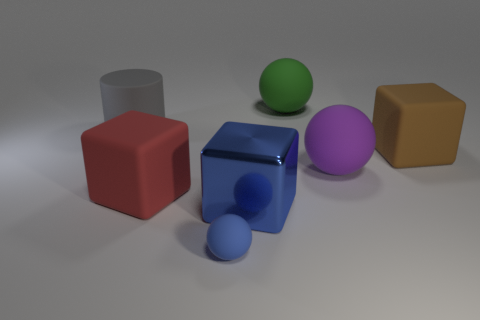Are there any other things that are the same material as the large blue thing?
Your response must be concise. No. Is the number of big cylinders to the right of the big metal block less than the number of large purple balls that are right of the tiny object?
Your response must be concise. Yes. There is a big purple matte object that is right of the object behind the gray object; what is its shape?
Your response must be concise. Sphere. Are any large green objects visible?
Your response must be concise. Yes. What is the color of the big matte cube behind the red matte cube?
Offer a terse response. Brown. There is another small thing that is the same color as the metallic thing; what material is it?
Give a very brief answer. Rubber. Are there any large matte things right of the gray object?
Your answer should be compact. Yes. Are there more big blue balls than big cubes?
Provide a succinct answer. No. There is a rubber cube in front of the large rubber block on the right side of the rubber block to the left of the small sphere; what color is it?
Give a very brief answer. Red. What color is the large cylinder that is the same material as the small sphere?
Provide a short and direct response. Gray. 